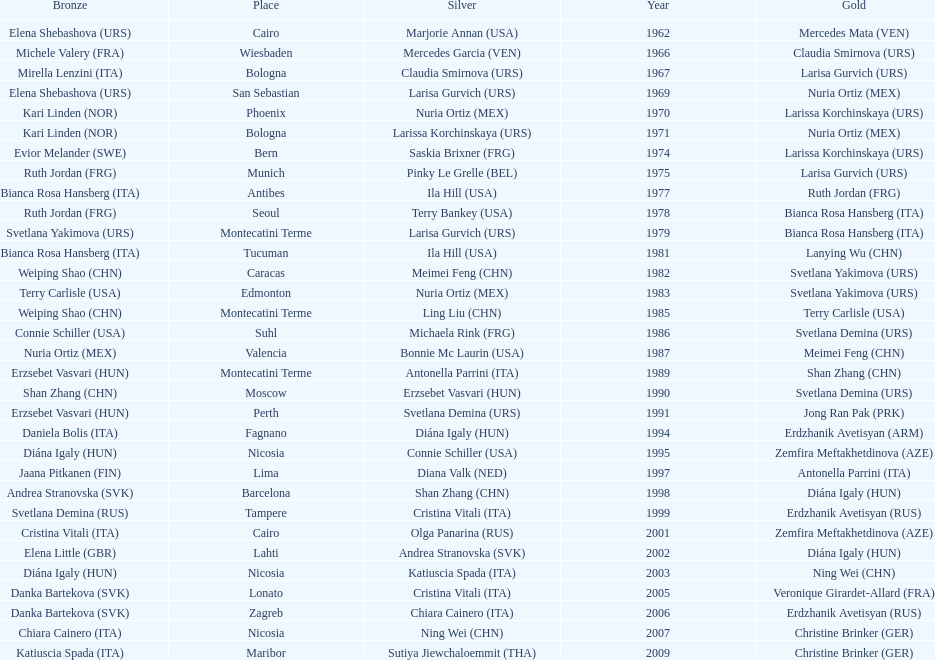Give me the full table as a dictionary. {'header': ['Bronze', 'Place', 'Silver', 'Year', 'Gold'], 'rows': [['Elena Shebashova\xa0(URS)', 'Cairo', 'Marjorie Annan\xa0(USA)', '1962', 'Mercedes Mata\xa0(VEN)'], ['Michele Valery\xa0(FRA)', 'Wiesbaden', 'Mercedes Garcia\xa0(VEN)', '1966', 'Claudia Smirnova\xa0(URS)'], ['Mirella Lenzini\xa0(ITA)', 'Bologna', 'Claudia Smirnova\xa0(URS)', '1967', 'Larisa Gurvich\xa0(URS)'], ['Elena Shebashova\xa0(URS)', 'San Sebastian', 'Larisa Gurvich\xa0(URS)', '1969', 'Nuria Ortiz\xa0(MEX)'], ['Kari Linden\xa0(NOR)', 'Phoenix', 'Nuria Ortiz\xa0(MEX)', '1970', 'Larissa Korchinskaya\xa0(URS)'], ['Kari Linden\xa0(NOR)', 'Bologna', 'Larissa Korchinskaya\xa0(URS)', '1971', 'Nuria Ortiz\xa0(MEX)'], ['Evior Melander\xa0(SWE)', 'Bern', 'Saskia Brixner\xa0(FRG)', '1974', 'Larissa Korchinskaya\xa0(URS)'], ['Ruth Jordan\xa0(FRG)', 'Munich', 'Pinky Le Grelle\xa0(BEL)', '1975', 'Larisa Gurvich\xa0(URS)'], ['Bianca Rosa Hansberg\xa0(ITA)', 'Antibes', 'Ila Hill\xa0(USA)', '1977', 'Ruth Jordan\xa0(FRG)'], ['Ruth Jordan\xa0(FRG)', 'Seoul', 'Terry Bankey\xa0(USA)', '1978', 'Bianca Rosa Hansberg\xa0(ITA)'], ['Svetlana Yakimova\xa0(URS)', 'Montecatini Terme', 'Larisa Gurvich\xa0(URS)', '1979', 'Bianca Rosa Hansberg\xa0(ITA)'], ['Bianca Rosa Hansberg\xa0(ITA)', 'Tucuman', 'Ila Hill\xa0(USA)', '1981', 'Lanying Wu\xa0(CHN)'], ['Weiping Shao\xa0(CHN)', 'Caracas', 'Meimei Feng\xa0(CHN)', '1982', 'Svetlana Yakimova\xa0(URS)'], ['Terry Carlisle\xa0(USA)', 'Edmonton', 'Nuria Ortiz\xa0(MEX)', '1983', 'Svetlana Yakimova\xa0(URS)'], ['Weiping Shao\xa0(CHN)', 'Montecatini Terme', 'Ling Liu\xa0(CHN)', '1985', 'Terry Carlisle\xa0(USA)'], ['Connie Schiller\xa0(USA)', 'Suhl', 'Michaela Rink\xa0(FRG)', '1986', 'Svetlana Demina\xa0(URS)'], ['Nuria Ortiz\xa0(MEX)', 'Valencia', 'Bonnie Mc Laurin\xa0(USA)', '1987', 'Meimei Feng\xa0(CHN)'], ['Erzsebet Vasvari\xa0(HUN)', 'Montecatini Terme', 'Antonella Parrini\xa0(ITA)', '1989', 'Shan Zhang\xa0(CHN)'], ['Shan Zhang\xa0(CHN)', 'Moscow', 'Erzsebet Vasvari\xa0(HUN)', '1990', 'Svetlana Demina\xa0(URS)'], ['Erzsebet Vasvari\xa0(HUN)', 'Perth', 'Svetlana Demina\xa0(URS)', '1991', 'Jong Ran Pak\xa0(PRK)'], ['Daniela Bolis\xa0(ITA)', 'Fagnano', 'Diána Igaly\xa0(HUN)', '1994', 'Erdzhanik Avetisyan\xa0(ARM)'], ['Diána Igaly\xa0(HUN)', 'Nicosia', 'Connie Schiller\xa0(USA)', '1995', 'Zemfira Meftakhetdinova\xa0(AZE)'], ['Jaana Pitkanen\xa0(FIN)', 'Lima', 'Diana Valk\xa0(NED)', '1997', 'Antonella Parrini\xa0(ITA)'], ['Andrea Stranovska\xa0(SVK)', 'Barcelona', 'Shan Zhang\xa0(CHN)', '1998', 'Diána Igaly\xa0(HUN)'], ['Svetlana Demina\xa0(RUS)', 'Tampere', 'Cristina Vitali\xa0(ITA)', '1999', 'Erdzhanik Avetisyan\xa0(RUS)'], ['Cristina Vitali\xa0(ITA)', 'Cairo', 'Olga Panarina\xa0(RUS)', '2001', 'Zemfira Meftakhetdinova\xa0(AZE)'], ['Elena Little\xa0(GBR)', 'Lahti', 'Andrea Stranovska\xa0(SVK)', '2002', 'Diána Igaly\xa0(HUN)'], ['Diána Igaly\xa0(HUN)', 'Nicosia', 'Katiuscia Spada\xa0(ITA)', '2003', 'Ning Wei\xa0(CHN)'], ['Danka Bartekova\xa0(SVK)', 'Lonato', 'Cristina Vitali\xa0(ITA)', '2005', 'Veronique Girardet-Allard\xa0(FRA)'], ['Danka Bartekova\xa0(SVK)', 'Zagreb', 'Chiara Cainero\xa0(ITA)', '2006', 'Erdzhanik Avetisyan\xa0(RUS)'], ['Chiara Cainero\xa0(ITA)', 'Nicosia', 'Ning Wei\xa0(CHN)', '2007', 'Christine Brinker\xa0(GER)'], ['Katiuscia Spada\xa0(ITA)', 'Maribor', 'Sutiya Jiewchaloemmit\xa0(THA)', '2009', 'Christine Brinker\xa0(GER)']]} How many gold did u.s.a win 1. 